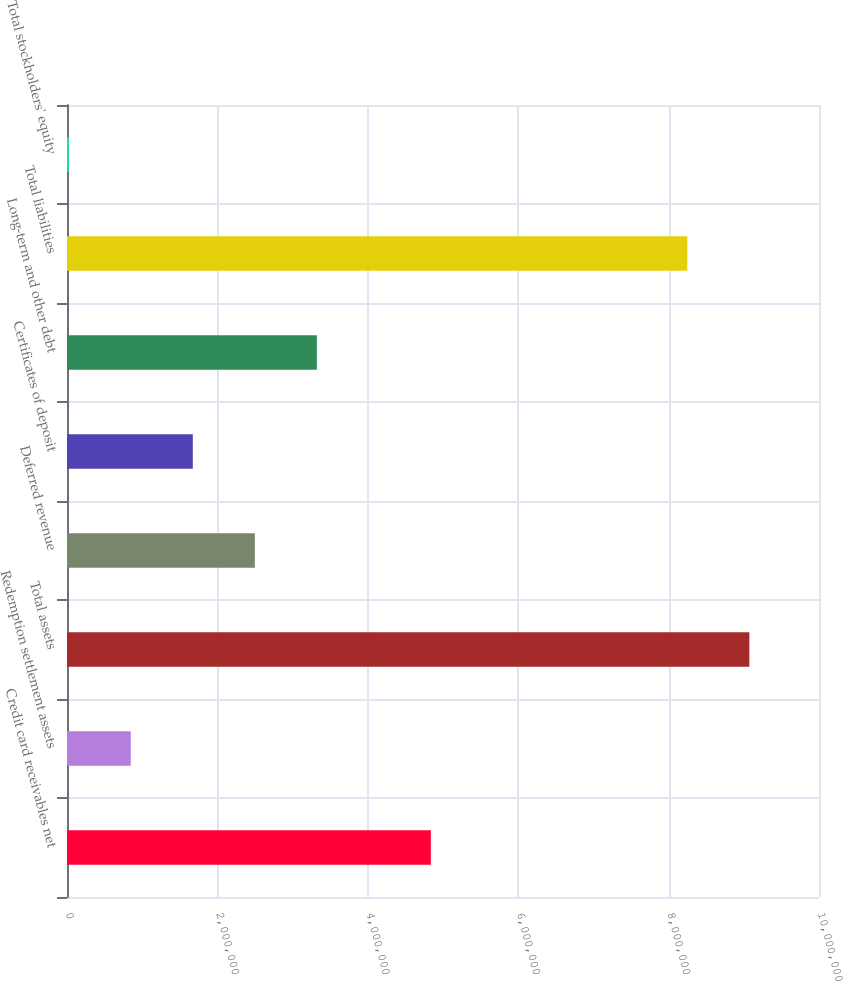<chart> <loc_0><loc_0><loc_500><loc_500><bar_chart><fcel>Credit card receivables net<fcel>Redemption settlement assets<fcel>Total assets<fcel>Deferred revenue<fcel>Certificates of deposit<fcel>Long-term and other debt<fcel>Total liabilities<fcel>Total stockholders' equity<nl><fcel>4.83835e+06<fcel>848000<fcel>9.07396e+06<fcel>2.49781e+06<fcel>1.67291e+06<fcel>3.32272e+06<fcel>8.24906e+06<fcel>23094<nl></chart> 